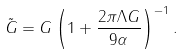Convert formula to latex. <formula><loc_0><loc_0><loc_500><loc_500>\tilde { G } = G \left ( 1 + \frac { 2 \pi \Lambda G } { 9 \alpha } \right ) ^ { - 1 } .</formula> 